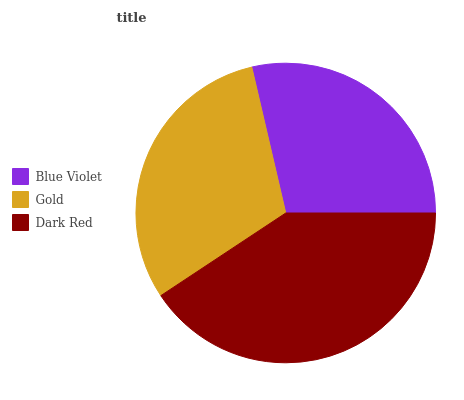Is Blue Violet the minimum?
Answer yes or no. Yes. Is Dark Red the maximum?
Answer yes or no. Yes. Is Gold the minimum?
Answer yes or no. No. Is Gold the maximum?
Answer yes or no. No. Is Gold greater than Blue Violet?
Answer yes or no. Yes. Is Blue Violet less than Gold?
Answer yes or no. Yes. Is Blue Violet greater than Gold?
Answer yes or no. No. Is Gold less than Blue Violet?
Answer yes or no. No. Is Gold the high median?
Answer yes or no. Yes. Is Gold the low median?
Answer yes or no. Yes. Is Blue Violet the high median?
Answer yes or no. No. Is Blue Violet the low median?
Answer yes or no. No. 